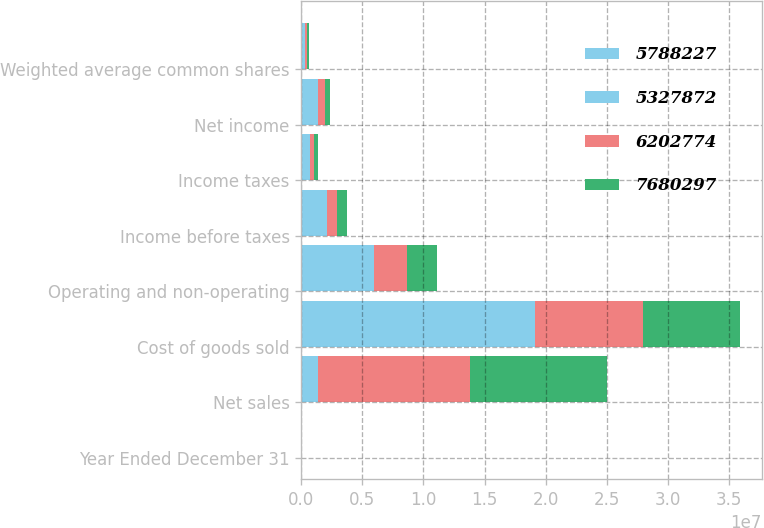Convert chart to OTSL. <chart><loc_0><loc_0><loc_500><loc_500><stacked_bar_chart><ecel><fcel>Year Ended December 31<fcel>Net sales<fcel>Cost of goods sold<fcel>Operating and non-operating<fcel>Income before taxes<fcel>Income taxes<fcel>Net income<fcel>Weighted average common shares<nl><fcel>5.78823e+06<fcel>2013<fcel>666500<fcel>9.85792e+06<fcel>3.17562e+06<fcel>1.0443e+06<fcel>359345<fcel>684959<fcel>155714<nl><fcel>5.32787e+06<fcel>2012<fcel>666500<fcel>9.23578e+06<fcel>2.75916e+06<fcel>1.01893e+06<fcel>370891<fcel>648041<fcel>156420<nl><fcel>6.20277e+06<fcel>2011<fcel>1.24589e+07<fcel>8.85284e+06<fcel>2.71523e+06<fcel>890806<fcel>325690<fcel>565116<fcel>157660<nl><fcel>7.6803e+06<fcel>2010<fcel>1.12076e+07<fcel>7.95464e+06<fcel>2.49116e+06<fcel>761783<fcel>286272<fcel>475511<fcel>158461<nl></chart> 